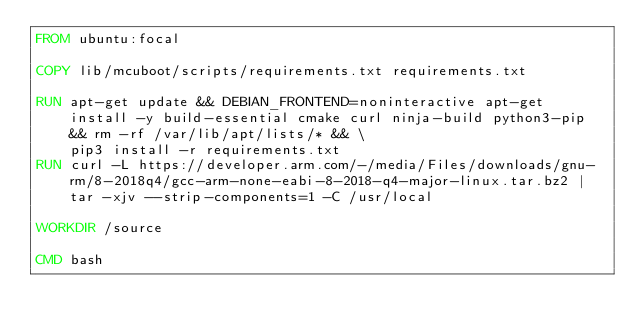Convert code to text. <code><loc_0><loc_0><loc_500><loc_500><_Dockerfile_>FROM ubuntu:focal

COPY lib/mcuboot/scripts/requirements.txt requirements.txt

RUN apt-get update && DEBIAN_FRONTEND=noninteractive apt-get install -y build-essential cmake curl ninja-build python3-pip && rm -rf /var/lib/apt/lists/* && \
    pip3 install -r requirements.txt
RUN curl -L https://developer.arm.com/-/media/Files/downloads/gnu-rm/8-2018q4/gcc-arm-none-eabi-8-2018-q4-major-linux.tar.bz2 | tar -xjv --strip-components=1 -C /usr/local

WORKDIR /source

CMD bash
</code> 